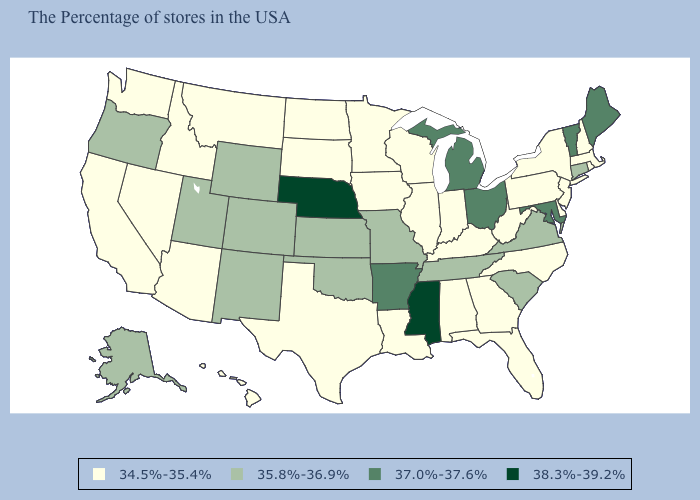What is the lowest value in the USA?
Quick response, please. 34.5%-35.4%. Name the states that have a value in the range 35.8%-36.9%?
Concise answer only. Connecticut, Virginia, South Carolina, Tennessee, Missouri, Kansas, Oklahoma, Wyoming, Colorado, New Mexico, Utah, Oregon, Alaska. Is the legend a continuous bar?
Quick response, please. No. What is the value of Indiana?
Be succinct. 34.5%-35.4%. Name the states that have a value in the range 38.3%-39.2%?
Be succinct. Mississippi, Nebraska. Does Massachusetts have a lower value than Connecticut?
Keep it brief. Yes. What is the value of Ohio?
Give a very brief answer. 37.0%-37.6%. Name the states that have a value in the range 37.0%-37.6%?
Write a very short answer. Maine, Vermont, Maryland, Ohio, Michigan, Arkansas. Which states have the lowest value in the USA?
Give a very brief answer. Massachusetts, Rhode Island, New Hampshire, New York, New Jersey, Delaware, Pennsylvania, North Carolina, West Virginia, Florida, Georgia, Kentucky, Indiana, Alabama, Wisconsin, Illinois, Louisiana, Minnesota, Iowa, Texas, South Dakota, North Dakota, Montana, Arizona, Idaho, Nevada, California, Washington, Hawaii. What is the lowest value in the USA?
Give a very brief answer. 34.5%-35.4%. What is the value of Louisiana?
Give a very brief answer. 34.5%-35.4%. Name the states that have a value in the range 35.8%-36.9%?
Be succinct. Connecticut, Virginia, South Carolina, Tennessee, Missouri, Kansas, Oklahoma, Wyoming, Colorado, New Mexico, Utah, Oregon, Alaska. What is the lowest value in the MidWest?
Be succinct. 34.5%-35.4%. Does Maine have the lowest value in the USA?
Keep it brief. No. What is the value of New Jersey?
Write a very short answer. 34.5%-35.4%. 